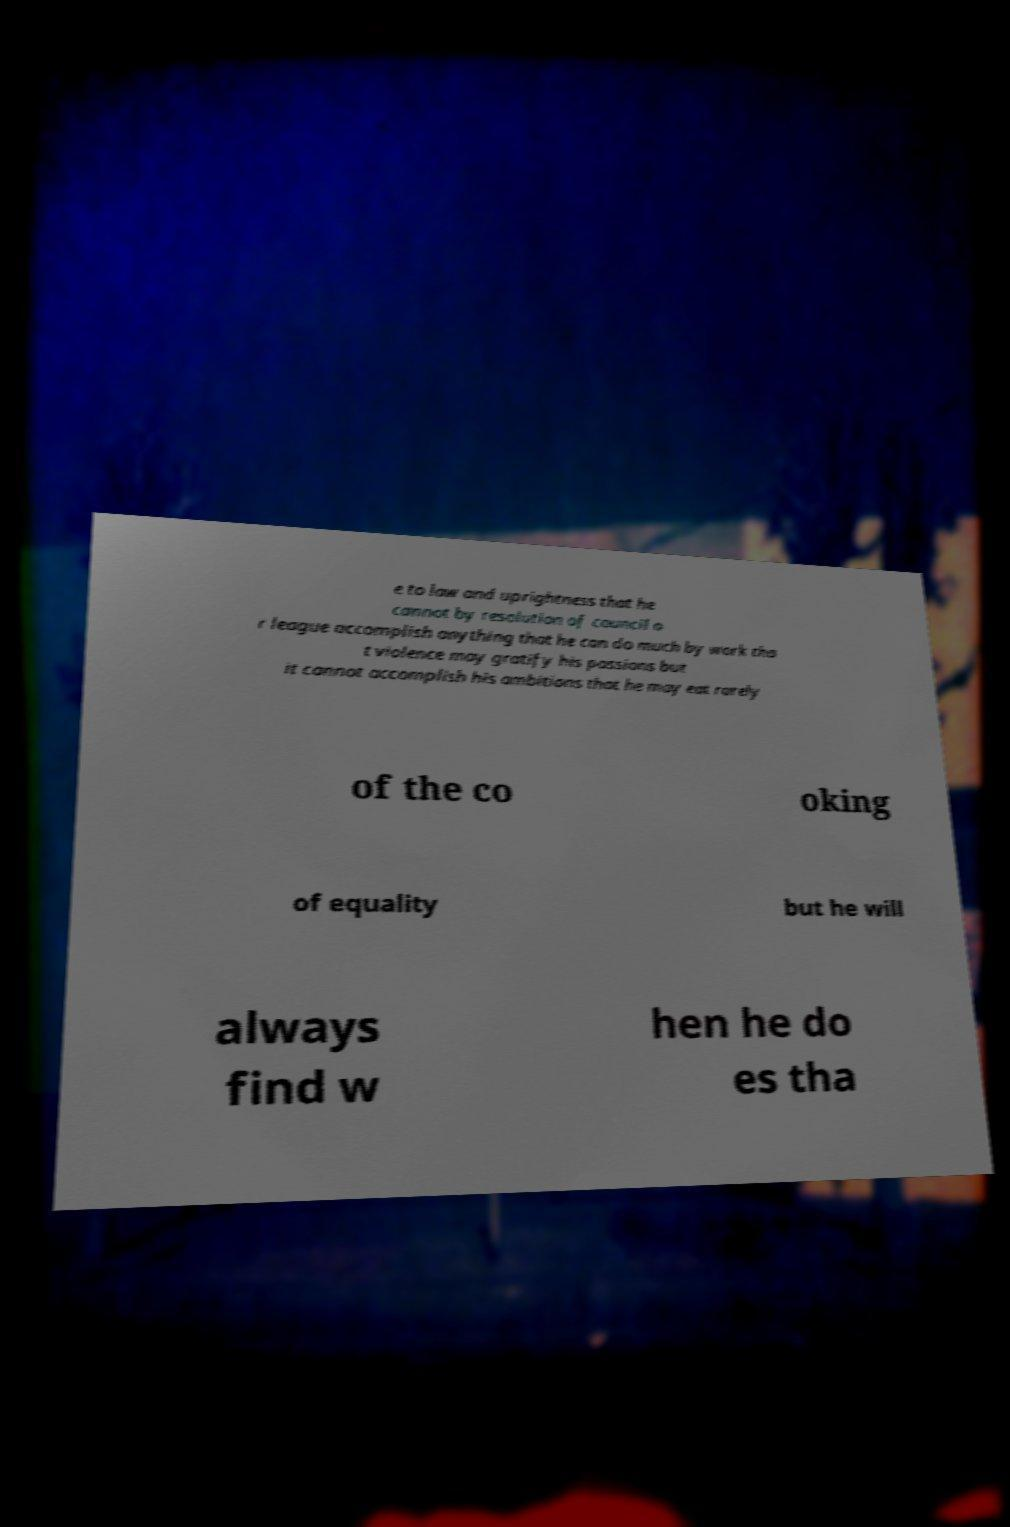Please identify and transcribe the text found in this image. e to law and uprightness that he cannot by resolution of council o r league accomplish anything that he can do much by work tha t violence may gratify his passions but it cannot accomplish his ambitions that he may eat rarely of the co oking of equality but he will always find w hen he do es tha 